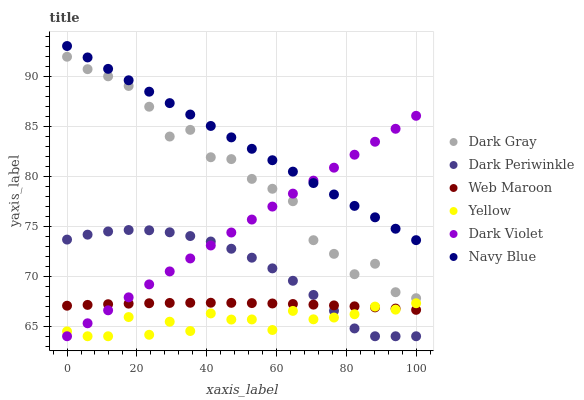Does Yellow have the minimum area under the curve?
Answer yes or no. Yes. Does Navy Blue have the maximum area under the curve?
Answer yes or no. Yes. Does Web Maroon have the minimum area under the curve?
Answer yes or no. No. Does Web Maroon have the maximum area under the curve?
Answer yes or no. No. Is Navy Blue the smoothest?
Answer yes or no. Yes. Is Dark Gray the roughest?
Answer yes or no. Yes. Is Web Maroon the smoothest?
Answer yes or no. No. Is Web Maroon the roughest?
Answer yes or no. No. Does Dark Violet have the lowest value?
Answer yes or no. Yes. Does Web Maroon have the lowest value?
Answer yes or no. No. Does Navy Blue have the highest value?
Answer yes or no. Yes. Does Web Maroon have the highest value?
Answer yes or no. No. Is Web Maroon less than Navy Blue?
Answer yes or no. Yes. Is Navy Blue greater than Dark Gray?
Answer yes or no. Yes. Does Yellow intersect Web Maroon?
Answer yes or no. Yes. Is Yellow less than Web Maroon?
Answer yes or no. No. Is Yellow greater than Web Maroon?
Answer yes or no. No. Does Web Maroon intersect Navy Blue?
Answer yes or no. No. 